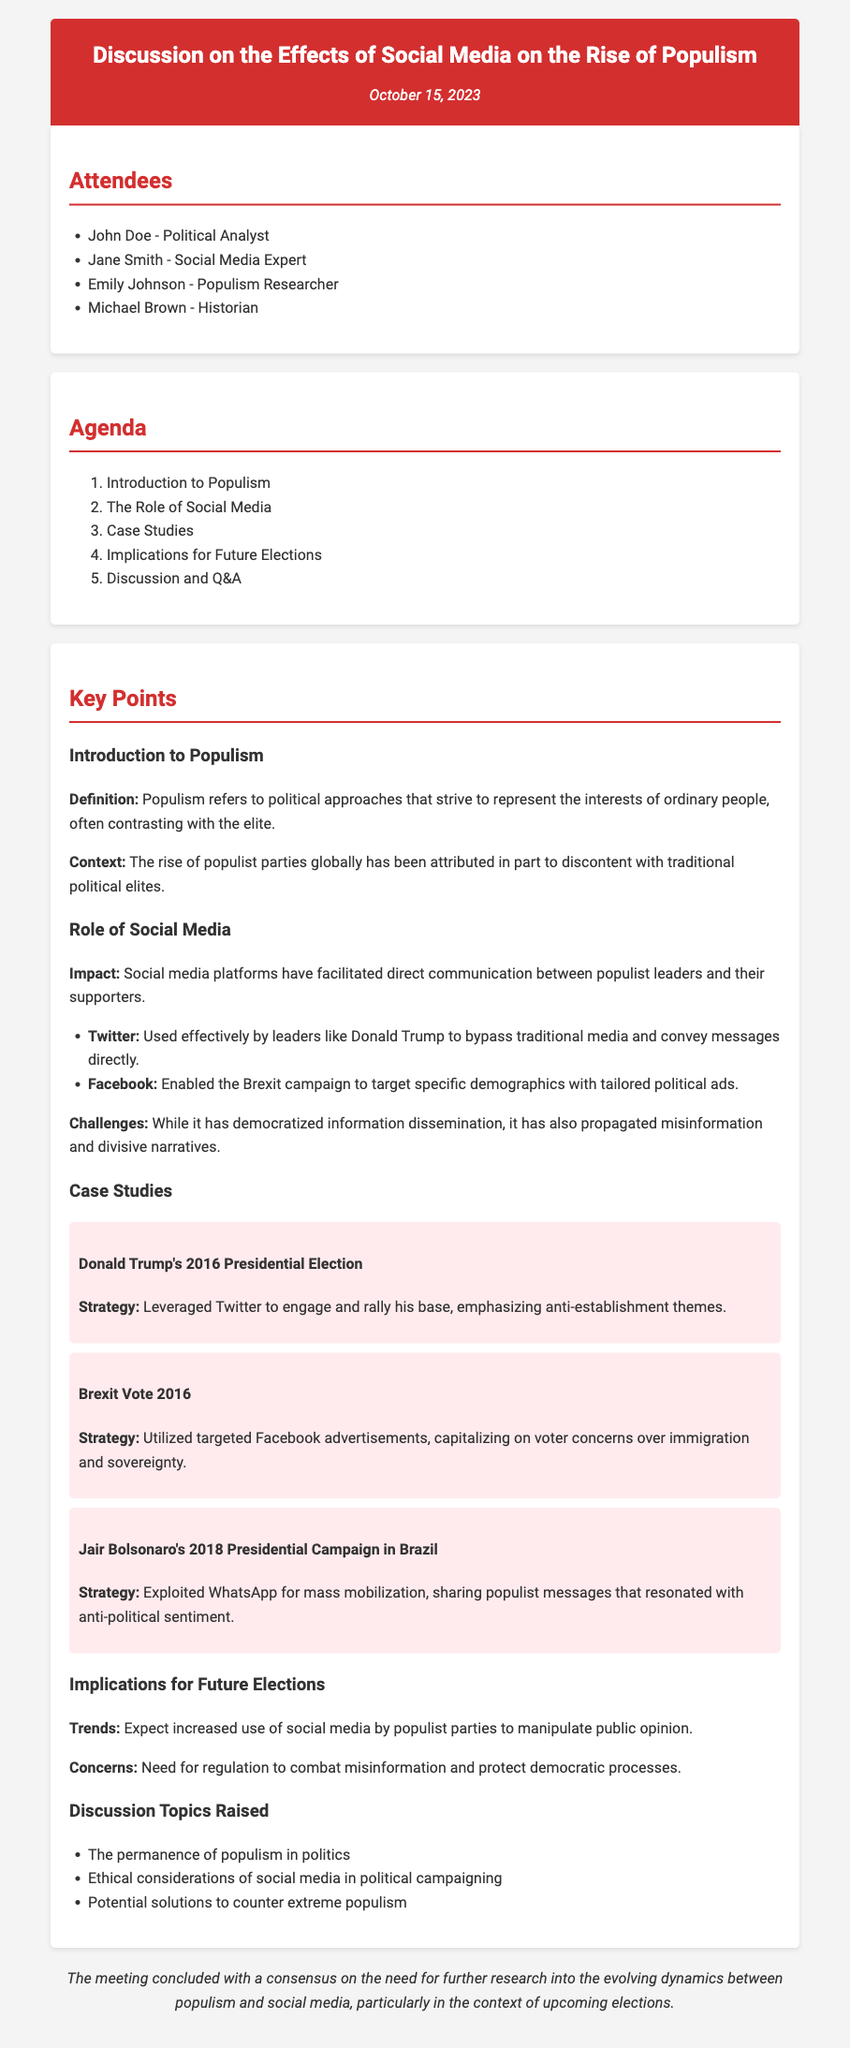What are the names of the attendees? The attendees are listed in the document under the "Attendees" section, which includes John Doe, Jane Smith, Emily Johnson, and Michael Brown.
Answer: John Doe, Jane Smith, Emily Johnson, Michael Brown What date was the meeting held? The date of the meeting is mentioned at the top of the document.
Answer: October 15, 2023 What was one case study mentioned in the discussion? The document lists several case studies under the "Case Studies" section, including Donald Trump's 2016 Presidential Election.
Answer: Donald Trump's 2016 Presidential Election What social media platform did Donald Trump effectively use? The document identifies Twitter as the platform used effectively by Donald Trump to convey messages directly.
Answer: Twitter What is a concern raised about social media in politics? The document states that there are concerns about the propagation of misinformation and divisive narratives in the context of social media.
Answer: Misinformation What was the primary strategy used in Jair Bolsonaro's campaign? The document details that Bolsonaro's strategy involved exploiting WhatsApp for mass mobilization with populist messages.
Answer: Exploited WhatsApp What is one of the discussion topics raised? The document lists discussion topics, one of which is the ethical considerations of social media in political campaigning.
Answer: Ethical considerations What trend is expected in future elections related to populism? The document predicts an increased use of social media by populist parties to manipulate public opinion.
Answer: Increased use of social media 